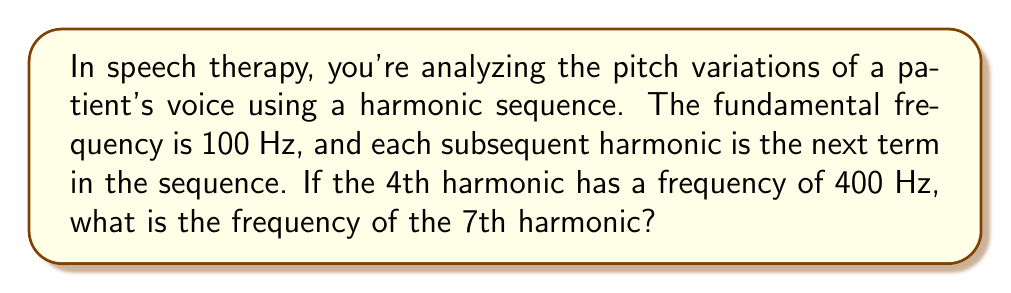What is the answer to this math problem? Let's approach this step-by-step:

1) In a harmonic sequence, the reciprocals of the terms form an arithmetic sequence. Let's denote the nth term of the harmonic sequence as $H_n$.

2) We're given that $H_1 = 100$ Hz (fundamental frequency) and $H_4 = 400$ Hz.

3) In a harmonic sequence, we have:

   $$\frac{1}{H_n} = a + (n-1)d$$

   where $a$ is the first term of the arithmetic sequence and $d$ is the common difference.

4) Using the given information:

   $$\frac{1}{100} = a$$
   $$\frac{1}{400} = a + 3d$$

5) Subtracting these equations:

   $$\frac{1}{100} - \frac{1}{400} = -3d$$
   $$\frac{3}{400} = -3d$$
   $$d = -\frac{1}{400}$$

6) Now we can find $a$:

   $$a = \frac{1}{100} = 0.01$$

7) For the 7th harmonic, we use $n = 7$:

   $$\frac{1}{H_7} = 0.01 + (7-1)(-\frac{1}{400}) = 0.01 - \frac{6}{400} = \frac{4-6}{400} = -\frac{1}{200}$$

8) Therefore:

   $$H_7 = -200 \text{ Hz}$$

9) Since frequency is always positive, we take the absolute value:

   $$H_7 = 200 \text{ Hz}$$
Answer: 200 Hz 